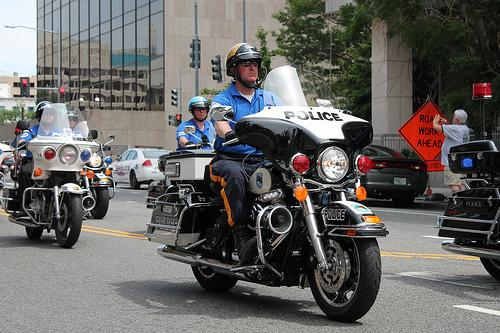Provide a succinct overview of the events unfolding in the image. Policemen ride motorcycles with red and blue lights down the street and wear helmets with sunglasses while a man works on a road sign, and another takes a photo near red traffic lights. Enumerate the most significant objects and occurrences in the image. Police on motorcycles, red and blue lights, sunglass-wearing policemen, road sign work, red traffic lights, and a man taking a photo. Give an overall description of what is happening in this image by mentioning the most essential objects and events. There are policemen riding motorcycles down the street, wearing helmets and sunglasses, while a man works on a road sign and people interact around a construction site. List the main components in the scene, along with the actions taking place around them. Police officers riding motorcycles with red and blue lights, a man working on an orange diamond-shaped sign, red traffic lights at an intersection, trees in the background, and a man taking a photo. Assemble a concise summary of what is happening in the image, including key elements and actions. In this image, police officers patrol on motorcycles with lights on, while a man works on a road sign, and another takes a photo near an intersection with red traffic lights. Pick out the most important aspects of the scene, and briefly describe what they are doing. Policemen patrol the road on motorcycles with red and blue lights, one man works on a road sign, and another takes a photograph, as traffic lights display red signals nearby. Using the details provided, paint a brief picture of the individuals and events depicted in the picture. Police officers wearing blue shirts with orange-striped pants, sunglasses, and helmets patrol on motorcycles with red and blue lights near an intersection with red traffic lights, as a man takes a photo and another works on a road sign. What is the most prevalent activity in the image, and who is involved in it? The most prevalent activity is police officers patrolling the street on motorcycles, wearing blue shirts, orange-striped pants, helmets, and sunglasses. What is the primary focus of the image, and how would you describe their actions? Police officers are riding on motorcycles, patrolling the road with their red and blue lights on, as others work nearby on a diamond-shaped road sign. What are the main events taking place in the image, and who is participating in them? The main events include police officers patrolling on motorcycles with red and blue lights, a man working on a road sign, and another taking a photograph near an intersection with red traffic lights. Please find the bear-shaped trash can near the orange construction sign. It's a creative way to encourage people to dispose of their waste properly. No, it's not mentioned in the image. How many lights can be seen on the motorcycle? two, a red light and a blue light Explain the type of sign seen nested along the street. a roadwork sign Describe the color and pattern of the pants worn by the police officer. blue pants with an orange stripe What unique feature does one police light have compared to another? One light is red, and another light is blue. Describe the environment in which the police officers are riding. They are riding on a street with yellow lines marking it, surrounded by buildings, trees, and traffic lights. Which of these objects can be seen on the motorcycle: (a) red light and blue light, (b) green light, (c) yellow light? (a) red light and blue light What event can be detected in this image? a police parade through a city Create a short story based on what you observe in the image. The guardians of the city paraded through the streets on their powerful motorcycles, all dressed in uniforms marked with orange stripes. As they traveled past construction signs and urban landscapes, curious citizens looked on, some documenting the event with their cameras. What emotion does the man next to the orange sign seem to exhibit? It's difficult to discern the emotion from the image. How would you describe the scene in a poetic manner? A parade of guardians on iron steeds, adorned with hues of blue and red, patrol the avenue of urban reflection. Where are the red lights located in the image? near the motorcycle and in the background What type of event could this image represent in a city setting? A police parade or patrol. What activity is the man next to the orange sign engaged in? taking a photo What are the police officers doing during the event?  Riding motorcycles down the road. What are the police riding on in the image? motorcycles Identify the words written on the fender of the motorcycle. police Is there a double yellow line in the image? Yes Is the red light in the foreground or background? foreground Explain the road sign in terms of its shape and color. an orange diamond-shaped sign What element of safety gear does the officer have on their head? a helmet 